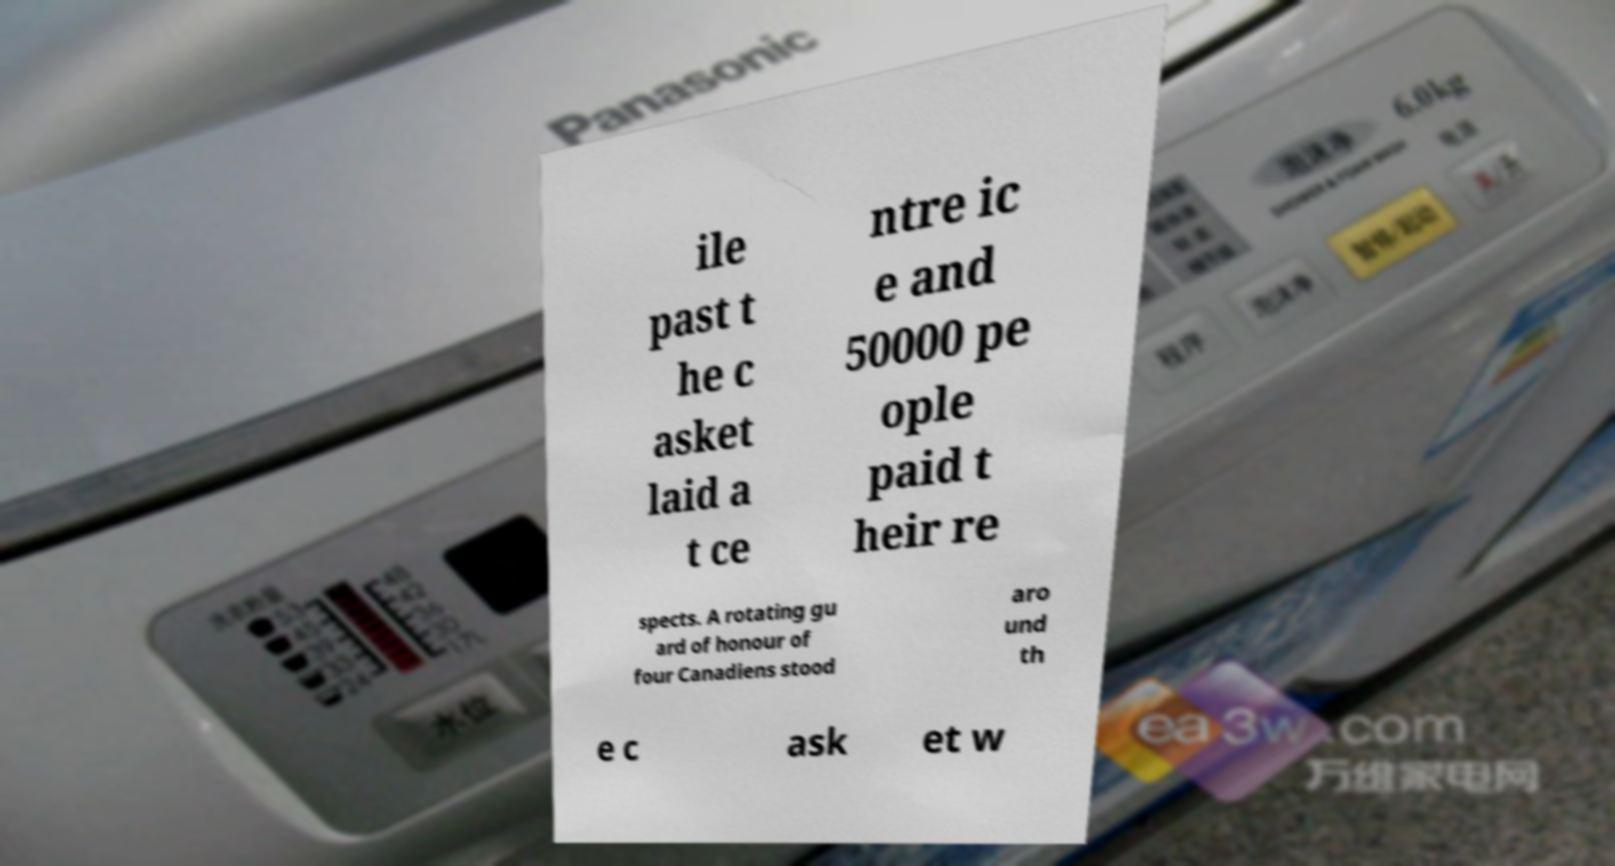Please read and relay the text visible in this image. What does it say? ile past t he c asket laid a t ce ntre ic e and 50000 pe ople paid t heir re spects. A rotating gu ard of honour of four Canadiens stood aro und th e c ask et w 